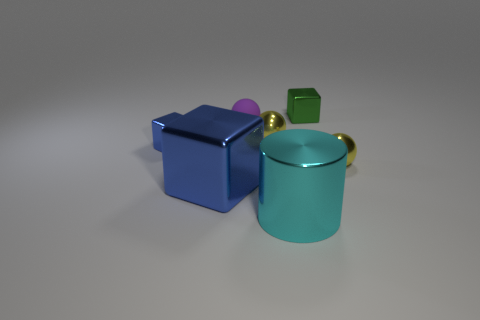Add 1 metallic objects. How many objects exist? 8 Subtract all cylinders. How many objects are left? 6 Add 1 large cubes. How many large cubes exist? 2 Subtract 0 cyan balls. How many objects are left? 7 Subtract all tiny purple matte spheres. Subtract all small rubber cylinders. How many objects are left? 6 Add 5 purple rubber objects. How many purple rubber objects are left? 6 